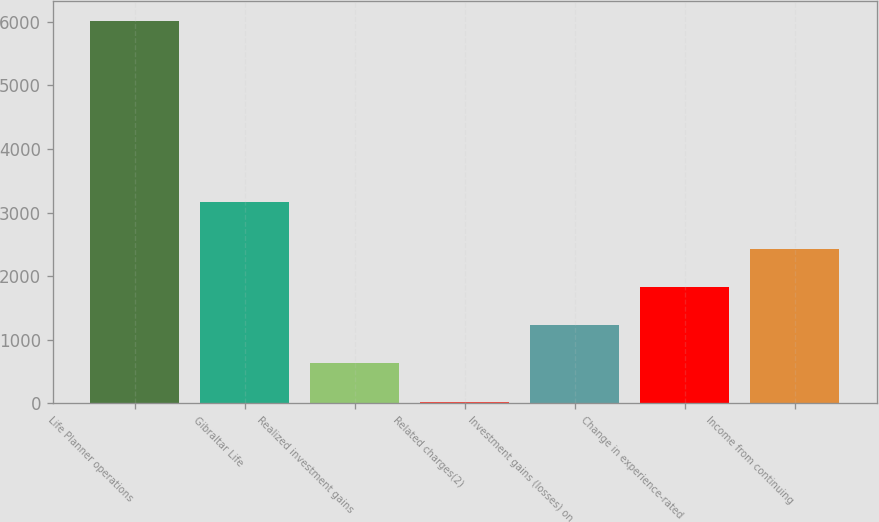<chart> <loc_0><loc_0><loc_500><loc_500><bar_chart><fcel>Life Planner operations<fcel>Gibraltar Life<fcel>Realized investment gains<fcel>Related charges(2)<fcel>Investment gains (losses) on<fcel>Change in experience-rated<fcel>Income from continuing<nl><fcel>6022<fcel>3163<fcel>626.5<fcel>27<fcel>1226<fcel>1825.5<fcel>2425<nl></chart> 